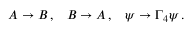<formula> <loc_0><loc_0><loc_500><loc_500>A \rightarrow B \, , \, B \rightarrow A \, , \, \psi \rightarrow \Gamma _ { 4 } \psi \, .</formula> 